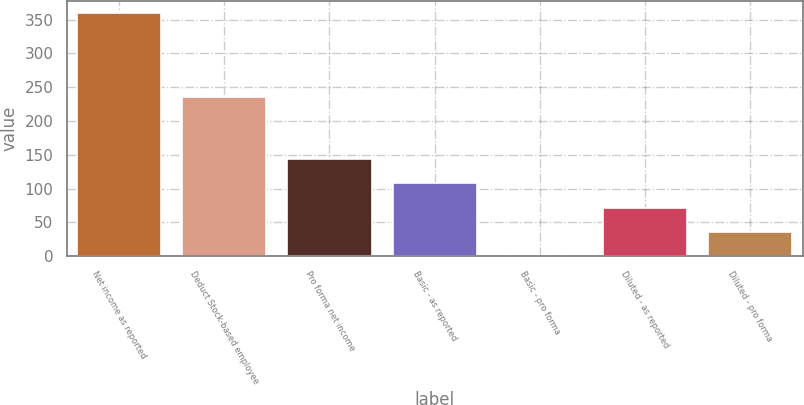Convert chart. <chart><loc_0><loc_0><loc_500><loc_500><bar_chart><fcel>Net income as reported<fcel>Deduct Stock-based employee<fcel>Pro forma net income<fcel>Basic - as reported<fcel>Basic - pro forma<fcel>Diluted - as reported<fcel>Diluted - pro forma<nl><fcel>360<fcel>235<fcel>144.04<fcel>108.05<fcel>0.08<fcel>72.06<fcel>36.07<nl></chart> 